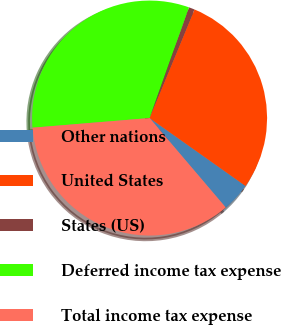Convert chart to OTSL. <chart><loc_0><loc_0><loc_500><loc_500><pie_chart><fcel>Other nations<fcel>United States<fcel>States (US)<fcel>Deferred income tax expense<fcel>Total income tax expense<nl><fcel>3.97%<fcel>28.57%<fcel>0.8%<fcel>31.75%<fcel>34.92%<nl></chart> 